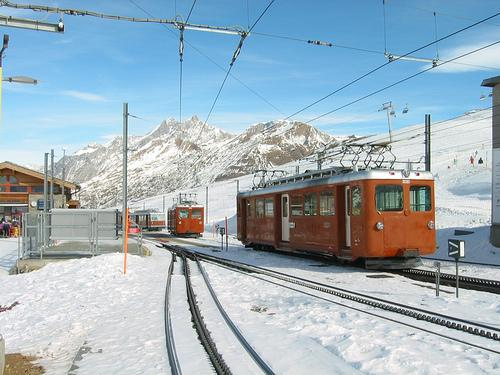Question: how many doors are on the closest train?
Choices:
A. One.
B. Three.
C. Four.
D. Two.
Answer with the letter. Answer: D Question: who uses the overhead lines?
Choices:
A. The trucks.
B. The trains.
C. The trams.
D. Residential use.
Answer with the letter. Answer: B Question: what color are the train cars?
Choices:
A. Red.
B. Orange.
C. White.
D. Blue.
Answer with the letter. Answer: B Question: what is covering the ground?
Choices:
A. Mud.
B. Leaves.
C. Snow.
D. Grass.
Answer with the letter. Answer: C Question: how many train tracks are there?
Choices:
A. One.
B. Three.
C. Two.
D. Four.
Answer with the letter. Answer: B 